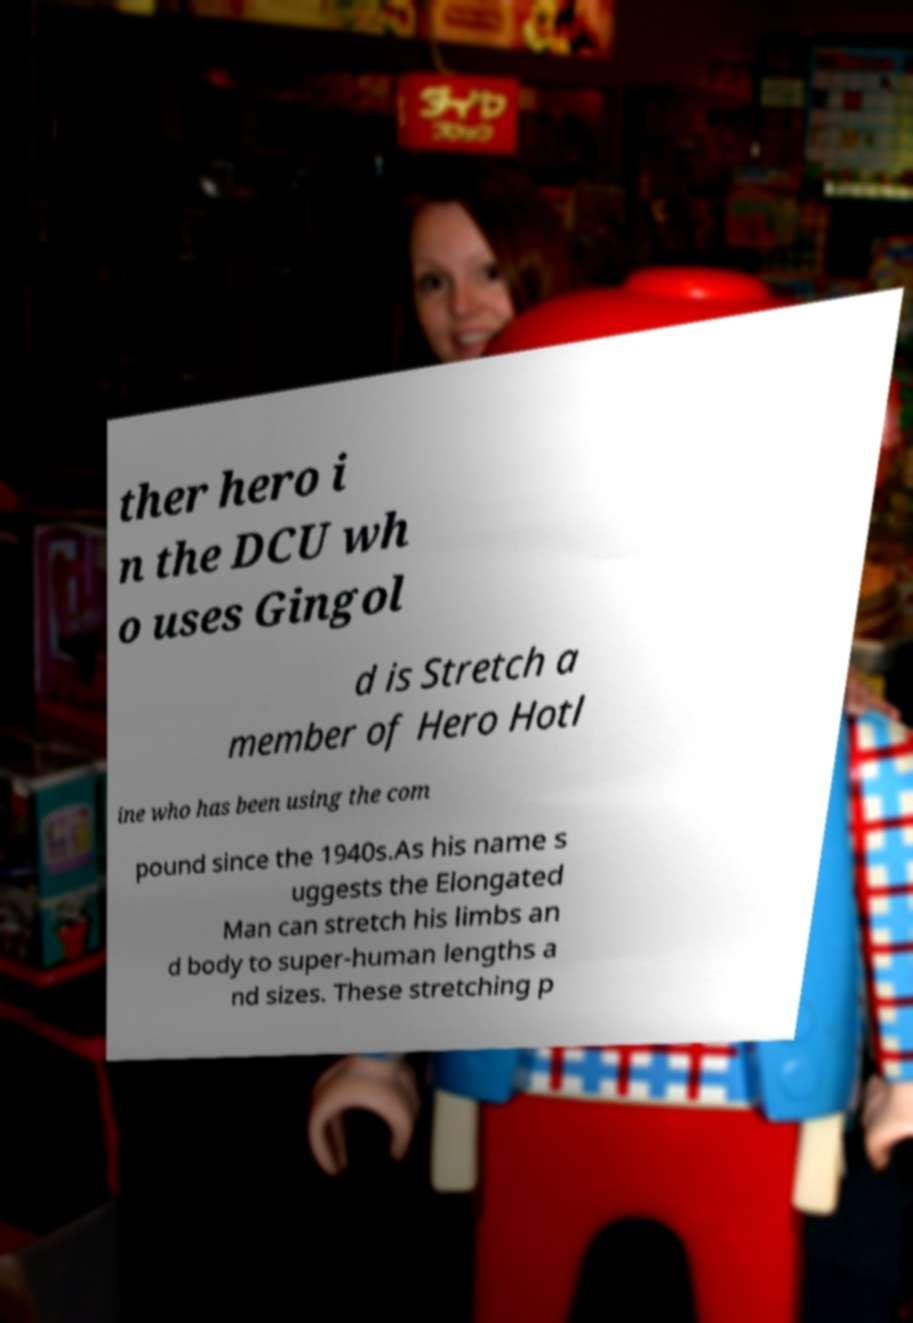Please identify and transcribe the text found in this image. ther hero i n the DCU wh o uses Gingol d is Stretch a member of Hero Hotl ine who has been using the com pound since the 1940s.As his name s uggests the Elongated Man can stretch his limbs an d body to super-human lengths a nd sizes. These stretching p 